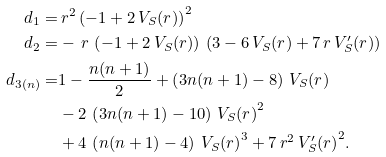Convert formula to latex. <formula><loc_0><loc_0><loc_500><loc_500>d _ { 1 } = & \, r ^ { 2 } \, { \left ( - 1 + 2 \, V _ { S } ( r ) \right ) } ^ { 2 } \\ d _ { 2 } = & - \, r \, \left ( - 1 + 2 \, V _ { S } ( r ) \right ) \, \left ( 3 - 6 \, V _ { S } ( r ) + 7 \, r \, V _ { S } ^ { \prime } ( r ) \right ) \\ d _ { 3 ( n ) } = & 1 - \frac { n ( n + 1 ) } 2 + \left ( 3 n ( n + 1 ) - 8 \right ) \, V _ { S } ( r ) \\ & - 2 \, \left ( 3 n ( n + 1 ) - 1 0 \right ) \, { V _ { S } ( r ) } ^ { 2 } \\ & + 4 \, \left ( n ( n + 1 ) - 4 \right ) \, { V _ { S } ( r ) } ^ { 3 } + 7 \, r ^ { 2 } \, { V _ { S } ^ { \prime } ( r ) } ^ { 2 } .</formula> 